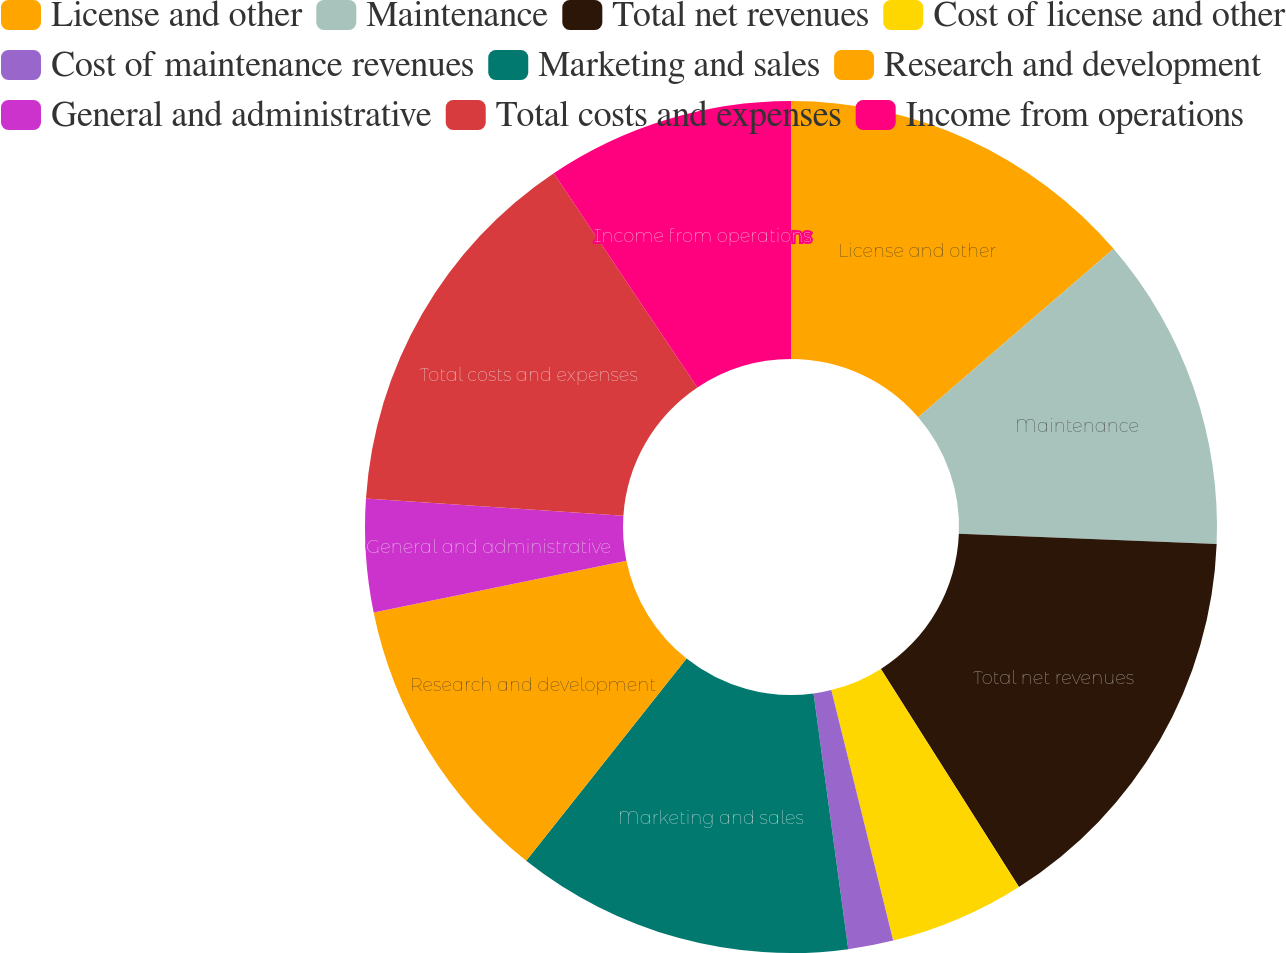Convert chart to OTSL. <chart><loc_0><loc_0><loc_500><loc_500><pie_chart><fcel>License and other<fcel>Maintenance<fcel>Total net revenues<fcel>Cost of license and other<fcel>Cost of maintenance revenues<fcel>Marketing and sales<fcel>Research and development<fcel>General and administrative<fcel>Total costs and expenses<fcel>Income from operations<nl><fcel>13.67%<fcel>11.96%<fcel>15.38%<fcel>5.13%<fcel>1.71%<fcel>12.82%<fcel>11.11%<fcel>4.28%<fcel>14.53%<fcel>9.4%<nl></chart> 